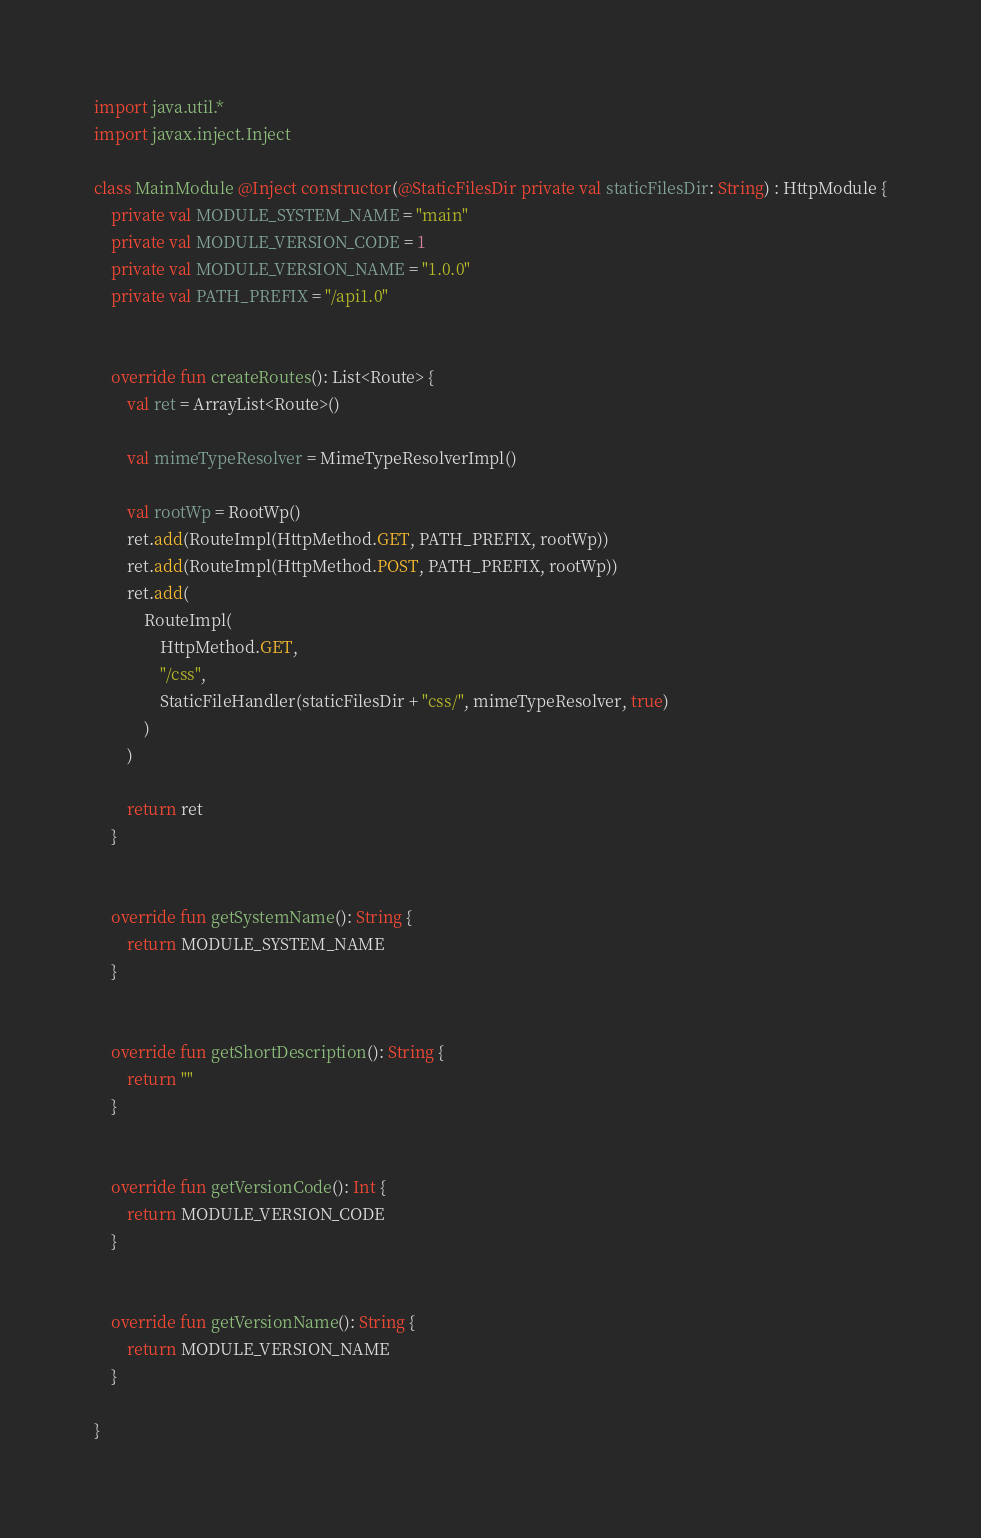Convert code to text. <code><loc_0><loc_0><loc_500><loc_500><_Kotlin_>import java.util.*
import javax.inject.Inject

class MainModule @Inject constructor(@StaticFilesDir private val staticFilesDir: String) : HttpModule {
    private val MODULE_SYSTEM_NAME = "main"
    private val MODULE_VERSION_CODE = 1
    private val MODULE_VERSION_NAME = "1.0.0"
    private val PATH_PREFIX = "/api1.0"


    override fun createRoutes(): List<Route> {
        val ret = ArrayList<Route>()

        val mimeTypeResolver = MimeTypeResolverImpl()

        val rootWp = RootWp()
        ret.add(RouteImpl(HttpMethod.GET, PATH_PREFIX, rootWp))
        ret.add(RouteImpl(HttpMethod.POST, PATH_PREFIX, rootWp))
        ret.add(
            RouteImpl(
                HttpMethod.GET,
                "/css",
                StaticFileHandler(staticFilesDir + "css/", mimeTypeResolver, true)
            )
        )

        return ret
    }


    override fun getSystemName(): String {
        return MODULE_SYSTEM_NAME
    }


    override fun getShortDescription(): String {
        return ""
    }


    override fun getVersionCode(): Int {
        return MODULE_VERSION_CODE
    }


    override fun getVersionName(): String {
        return MODULE_VERSION_NAME
    }

}</code> 